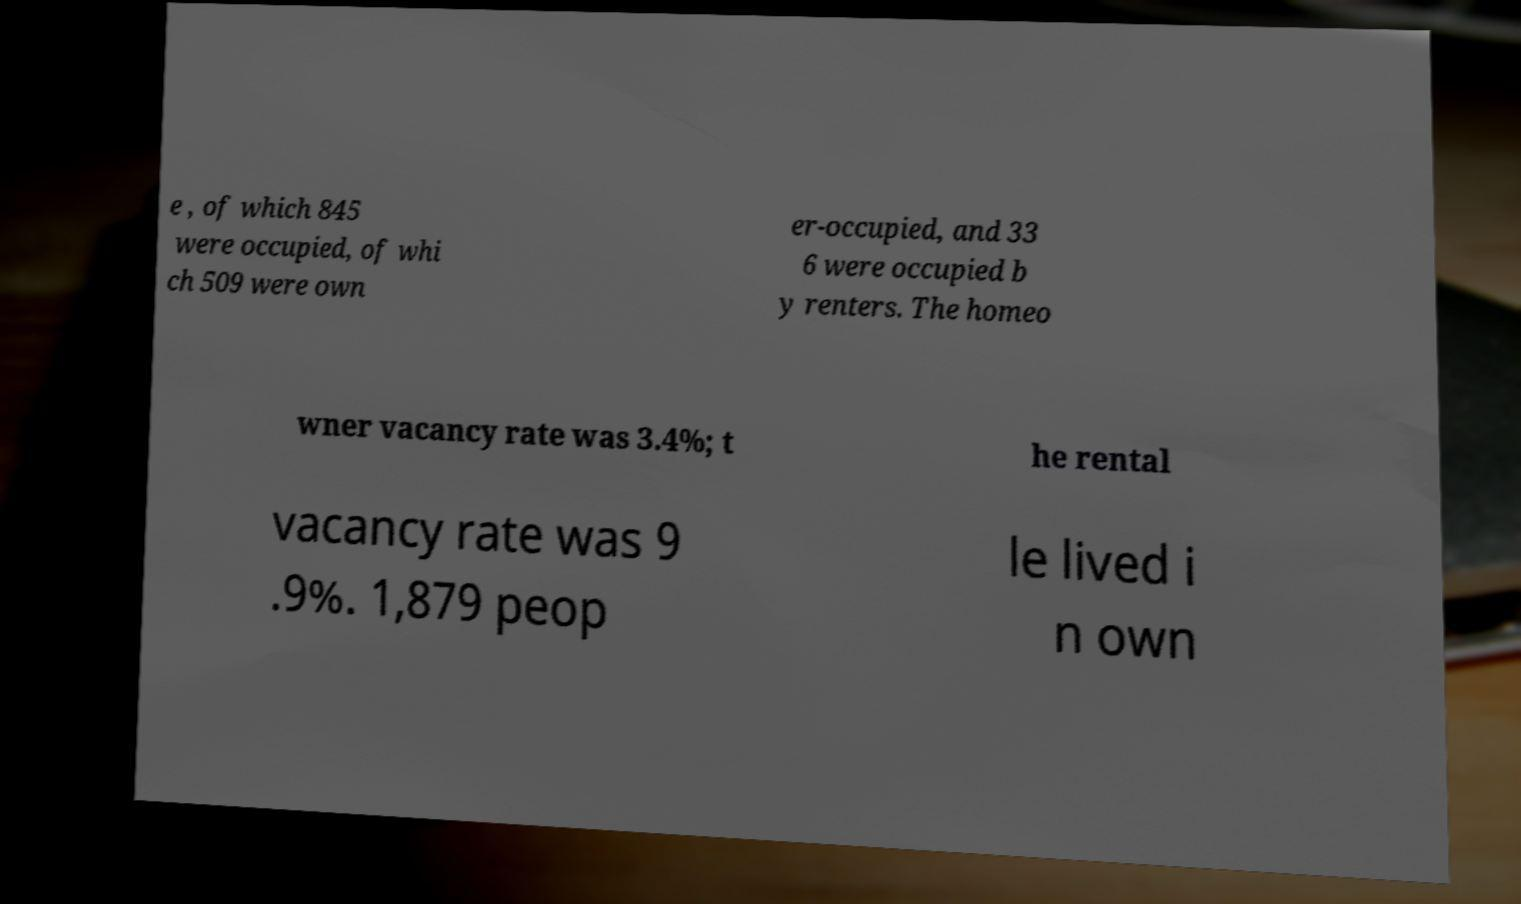There's text embedded in this image that I need extracted. Can you transcribe it verbatim? e , of which 845 were occupied, of whi ch 509 were own er-occupied, and 33 6 were occupied b y renters. The homeo wner vacancy rate was 3.4%; t he rental vacancy rate was 9 .9%. 1,879 peop le lived i n own 